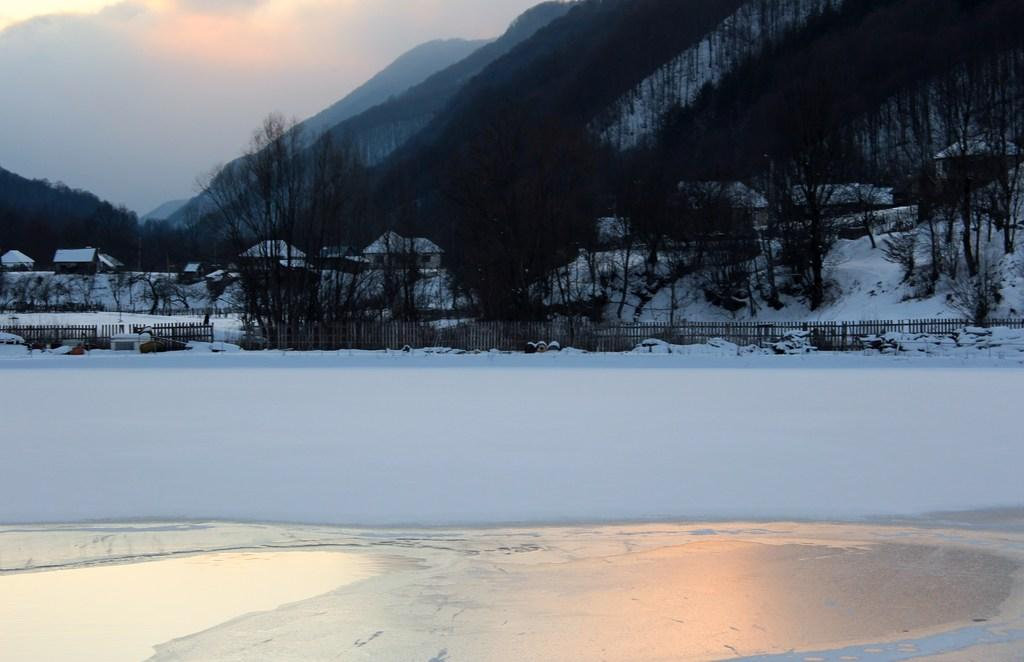What type of landscape is depicted in the image? The image features many mountains. What is the weather like in the image? There is snow visible in the image, indicating a cold climate. Are there any human-made structures in the image? Yes, there are houses in the image. What type of barrier can be seen in the image? There is a fence in the image. What type of vegetation is present in the image? There are many trees in the image. What type of letter is being used to hold the screws in the image? There is no letter or screws present in the image; it features mountains, snow, houses, a fence, and trees. 